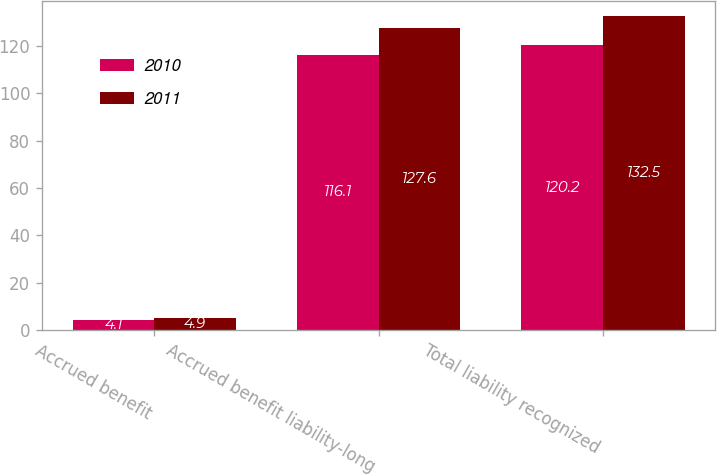<chart> <loc_0><loc_0><loc_500><loc_500><stacked_bar_chart><ecel><fcel>Accrued benefit<fcel>Accrued benefit liability-long<fcel>Total liability recognized<nl><fcel>2010<fcel>4.1<fcel>116.1<fcel>120.2<nl><fcel>2011<fcel>4.9<fcel>127.6<fcel>132.5<nl></chart> 